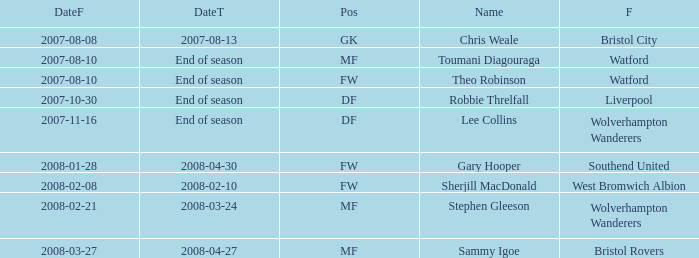What was the name for the row with Date From of 2008-02-21? Stephen Gleeson. 